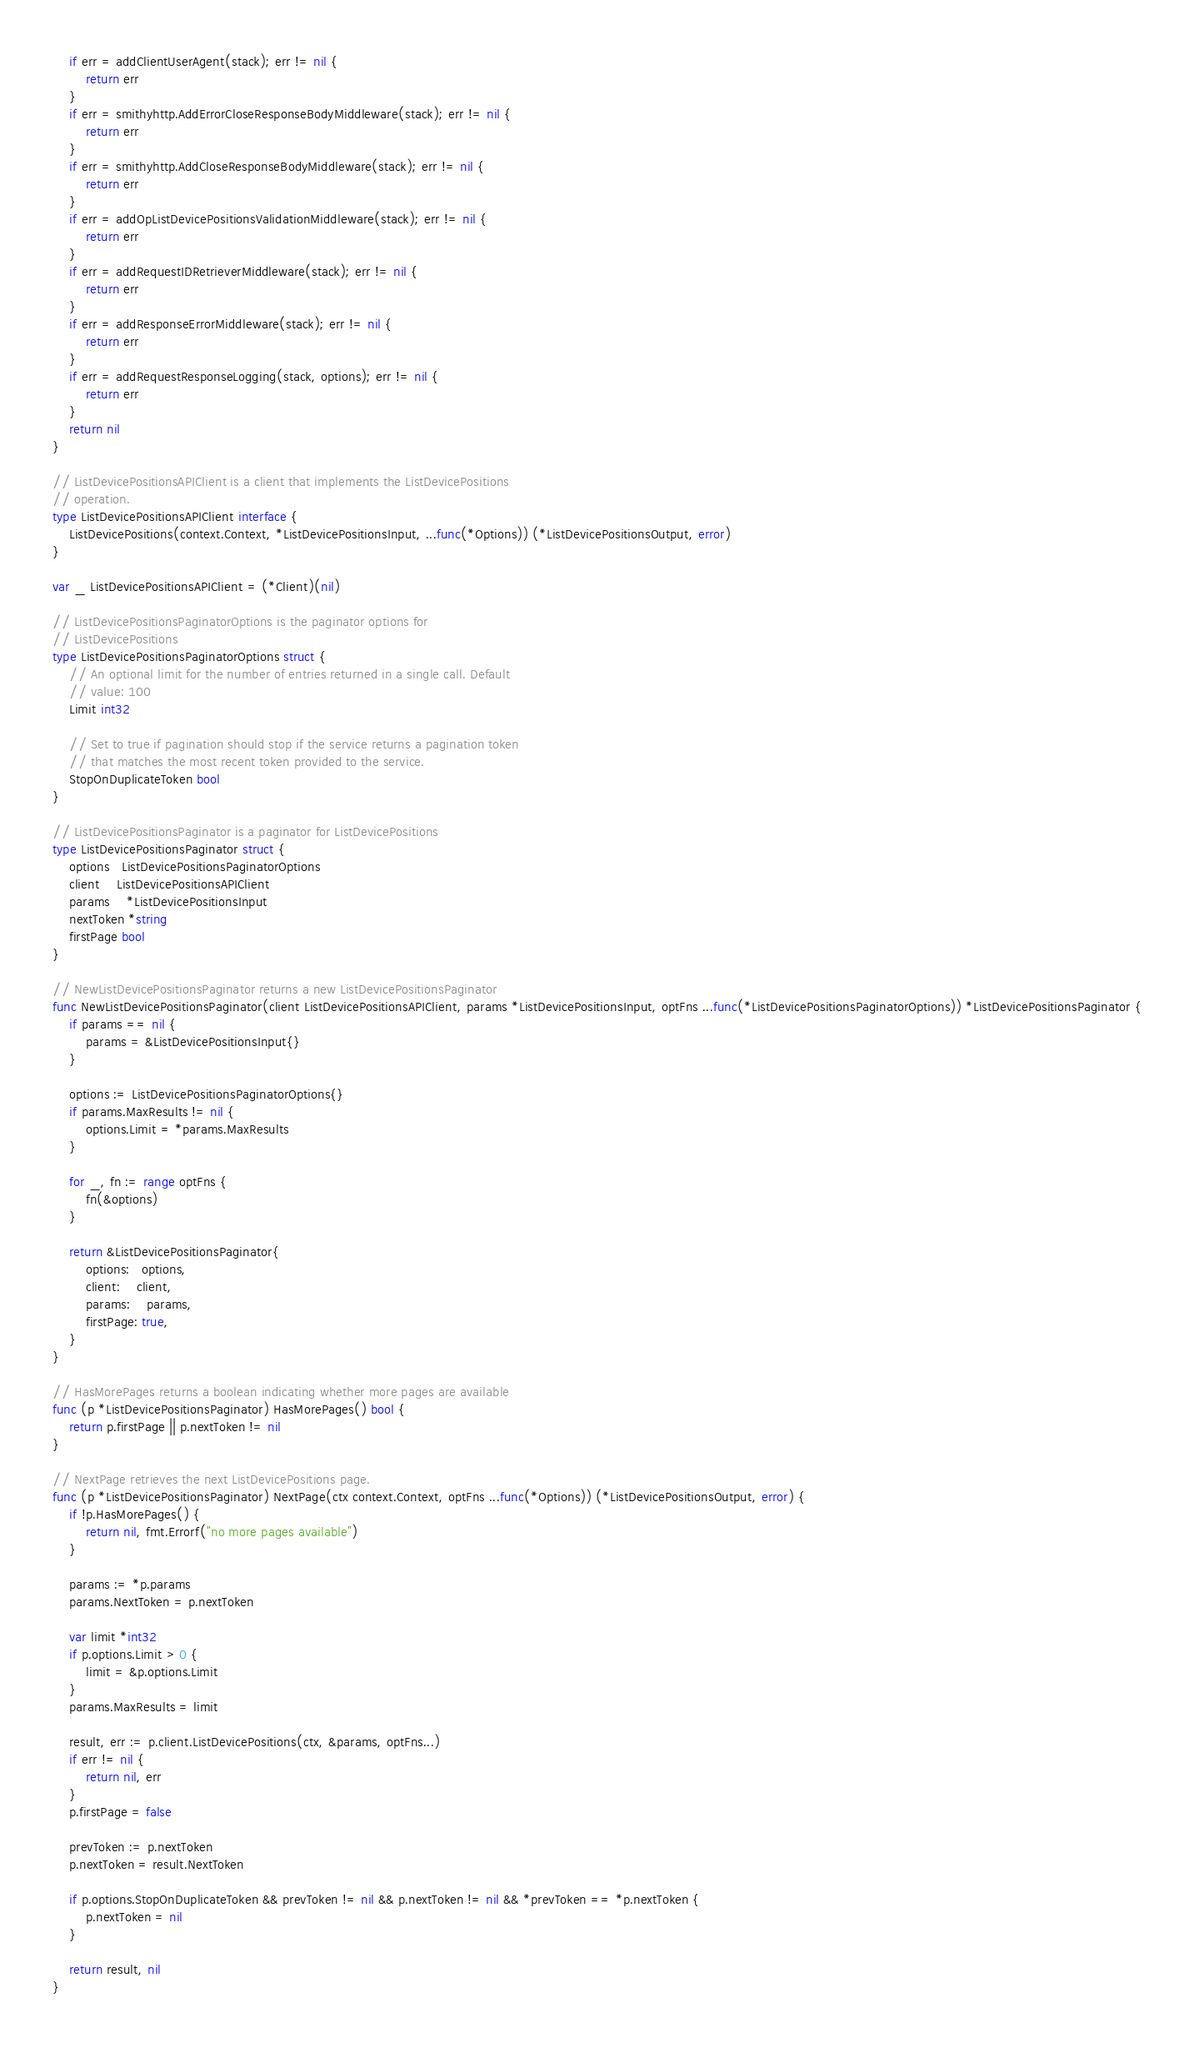<code> <loc_0><loc_0><loc_500><loc_500><_Go_>	if err = addClientUserAgent(stack); err != nil {
		return err
	}
	if err = smithyhttp.AddErrorCloseResponseBodyMiddleware(stack); err != nil {
		return err
	}
	if err = smithyhttp.AddCloseResponseBodyMiddleware(stack); err != nil {
		return err
	}
	if err = addOpListDevicePositionsValidationMiddleware(stack); err != nil {
		return err
	}
	if err = addRequestIDRetrieverMiddleware(stack); err != nil {
		return err
	}
	if err = addResponseErrorMiddleware(stack); err != nil {
		return err
	}
	if err = addRequestResponseLogging(stack, options); err != nil {
		return err
	}
	return nil
}

// ListDevicePositionsAPIClient is a client that implements the ListDevicePositions
// operation.
type ListDevicePositionsAPIClient interface {
	ListDevicePositions(context.Context, *ListDevicePositionsInput, ...func(*Options)) (*ListDevicePositionsOutput, error)
}

var _ ListDevicePositionsAPIClient = (*Client)(nil)

// ListDevicePositionsPaginatorOptions is the paginator options for
// ListDevicePositions
type ListDevicePositionsPaginatorOptions struct {
	// An optional limit for the number of entries returned in a single call. Default
	// value: 100
	Limit int32

	// Set to true if pagination should stop if the service returns a pagination token
	// that matches the most recent token provided to the service.
	StopOnDuplicateToken bool
}

// ListDevicePositionsPaginator is a paginator for ListDevicePositions
type ListDevicePositionsPaginator struct {
	options   ListDevicePositionsPaginatorOptions
	client    ListDevicePositionsAPIClient
	params    *ListDevicePositionsInput
	nextToken *string
	firstPage bool
}

// NewListDevicePositionsPaginator returns a new ListDevicePositionsPaginator
func NewListDevicePositionsPaginator(client ListDevicePositionsAPIClient, params *ListDevicePositionsInput, optFns ...func(*ListDevicePositionsPaginatorOptions)) *ListDevicePositionsPaginator {
	if params == nil {
		params = &ListDevicePositionsInput{}
	}

	options := ListDevicePositionsPaginatorOptions{}
	if params.MaxResults != nil {
		options.Limit = *params.MaxResults
	}

	for _, fn := range optFns {
		fn(&options)
	}

	return &ListDevicePositionsPaginator{
		options:   options,
		client:    client,
		params:    params,
		firstPage: true,
	}
}

// HasMorePages returns a boolean indicating whether more pages are available
func (p *ListDevicePositionsPaginator) HasMorePages() bool {
	return p.firstPage || p.nextToken != nil
}

// NextPage retrieves the next ListDevicePositions page.
func (p *ListDevicePositionsPaginator) NextPage(ctx context.Context, optFns ...func(*Options)) (*ListDevicePositionsOutput, error) {
	if !p.HasMorePages() {
		return nil, fmt.Errorf("no more pages available")
	}

	params := *p.params
	params.NextToken = p.nextToken

	var limit *int32
	if p.options.Limit > 0 {
		limit = &p.options.Limit
	}
	params.MaxResults = limit

	result, err := p.client.ListDevicePositions(ctx, &params, optFns...)
	if err != nil {
		return nil, err
	}
	p.firstPage = false

	prevToken := p.nextToken
	p.nextToken = result.NextToken

	if p.options.StopOnDuplicateToken && prevToken != nil && p.nextToken != nil && *prevToken == *p.nextToken {
		p.nextToken = nil
	}

	return result, nil
}
</code> 